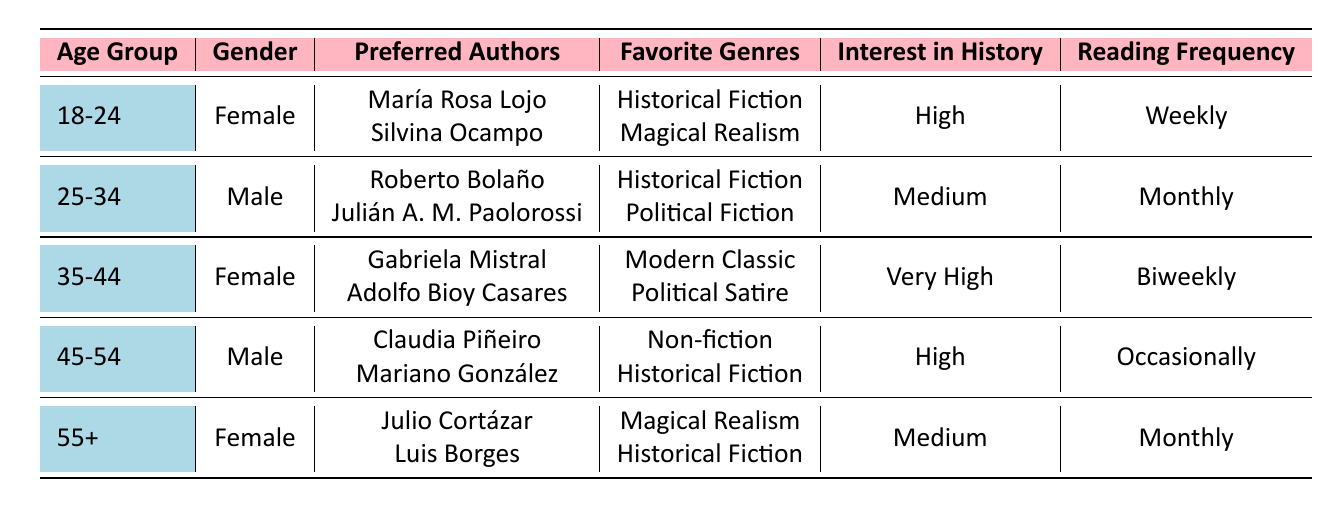What is the most preferred genre among readers aged 18-24? According to the table, readers aged 18-24 prefer "Historical Fiction" and "Magical Realism," but "Historical Fiction" is listed first, indicating it is the most preferred genre.
Answer: Historical Fiction How often do readers aged 45-54 read? The table indicates that readers aged 45-54 read "Occasionally," which is their selected reading frequency.
Answer: Occasionally Which author is preferred by female readers aged 35-44? The table shows that female readers in the 35-44 age group prefer "Gabriela Mistral" and "Adolfo Bioy Casares."
Answer: Gabriela Mistral What is the highest interest level in history among the age groups? The highest interest level in history is "Very High," which corresponds to the 35-44 age group.
Answer: Very High Do any male readers prefer "Magical Realism"? The table shows that male readers do not list "Magical Realism" as a preferred genre, indicating that the answer is no.
Answer: No How many readers have "Historical Fiction" as one of their favorite genres? From the table, it appears in the preferences of readers aged 18-24, 25-34, 35-44, and 45-54. This totals four different readers.
Answer: Four Which age group has the highest number of preferred authors listed? Each age group has two preferred authors, so there is no age group with a higher number; they all have the same count.
Answer: None (all have the same count) What is the average reading frequency across all age groups? The reading frequencies can be categorized into "Weekly," "Monthly," "Biweekly," and "Occasionally," which can be assigned numerical values (Weekly = 4, Monthly = 3, Biweekly = 2, Occasionally = 1). Calculating the average involves adding their numerical values together and then dividing by the number of age groups (5), which yields an average of approximately 2.4.
Answer: Approximately 2.4 What preferences do female readers aged 55 and over share with other groups? Female readers aged 55 and over share a preference for "Historical Fiction" with readers aged 18-24, 35-44, and 45-54. However, they also have a unique preference for "Magical Realism."
Answer: Historical Fiction Which gender has more representation in the 25-34 age group for preferred authors? The 25-34 age group is represented by male readers, showing no female representation in this group regarding preferred authors.
Answer: Male How many genres are preferred among the readers aged 45-54? According to the table, readers aged 45-54 prefer "Non-fiction" and "Historical Fiction," which totals two distinct genres.
Answer: Two 